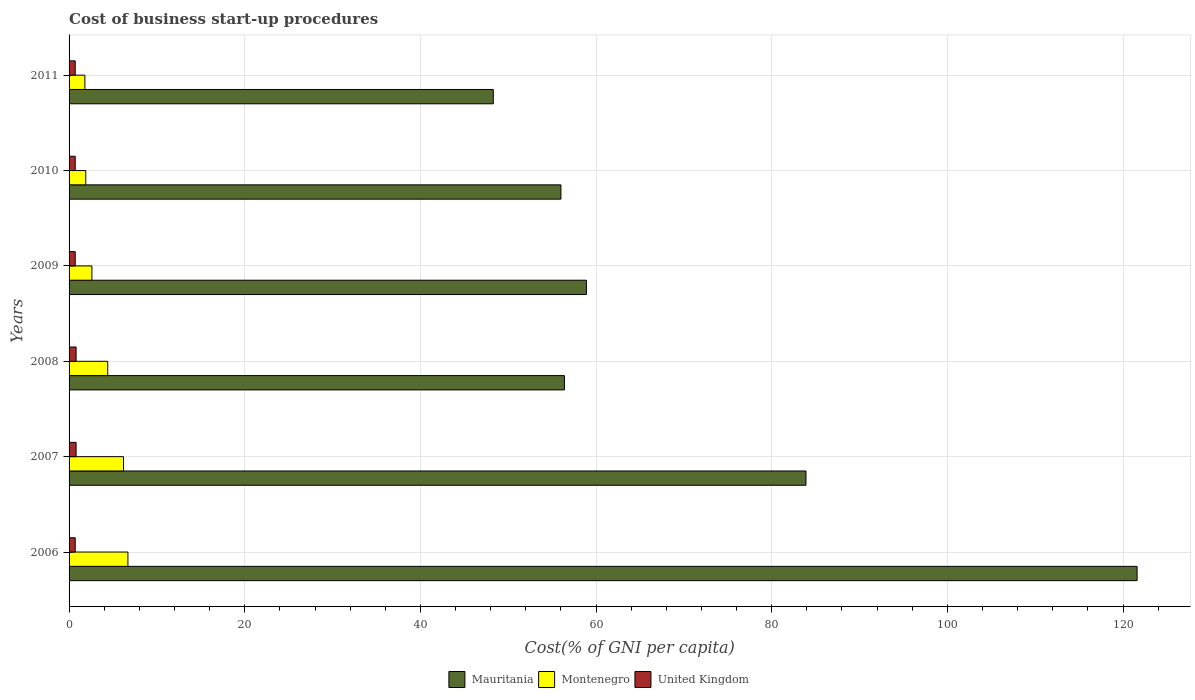How many groups of bars are there?
Give a very brief answer. 6. How many bars are there on the 3rd tick from the bottom?
Your answer should be very brief. 3. What is the label of the 2nd group of bars from the top?
Your answer should be compact. 2010. What is the cost of business start-up procedures in Montenegro in 2006?
Make the answer very short. 6.7. Across all years, what is the maximum cost of business start-up procedures in Mauritania?
Provide a short and direct response. 121.6. Across all years, what is the minimum cost of business start-up procedures in United Kingdom?
Make the answer very short. 0.7. What is the total cost of business start-up procedures in Mauritania in the graph?
Your answer should be very brief. 425.1. What is the difference between the cost of business start-up procedures in United Kingdom in 2008 and that in 2009?
Provide a succinct answer. 0.1. What is the difference between the cost of business start-up procedures in Mauritania in 2010 and the cost of business start-up procedures in Montenegro in 2011?
Make the answer very short. 54.2. What is the average cost of business start-up procedures in Montenegro per year?
Give a very brief answer. 3.93. In the year 2010, what is the difference between the cost of business start-up procedures in Mauritania and cost of business start-up procedures in Montenegro?
Provide a short and direct response. 54.1. What is the ratio of the cost of business start-up procedures in Montenegro in 2007 to that in 2010?
Provide a succinct answer. 3.26. Is the cost of business start-up procedures in Mauritania in 2006 less than that in 2008?
Keep it short and to the point. No. What is the difference between the highest and the second highest cost of business start-up procedures in Mauritania?
Provide a short and direct response. 37.7. What is the difference between the highest and the lowest cost of business start-up procedures in Mauritania?
Offer a terse response. 73.3. In how many years, is the cost of business start-up procedures in United Kingdom greater than the average cost of business start-up procedures in United Kingdom taken over all years?
Make the answer very short. 2. Is the sum of the cost of business start-up procedures in Mauritania in 2010 and 2011 greater than the maximum cost of business start-up procedures in Montenegro across all years?
Your answer should be compact. Yes. What does the 2nd bar from the top in 2008 represents?
Keep it short and to the point. Montenegro. What does the 2nd bar from the bottom in 2007 represents?
Your response must be concise. Montenegro. Is it the case that in every year, the sum of the cost of business start-up procedures in United Kingdom and cost of business start-up procedures in Mauritania is greater than the cost of business start-up procedures in Montenegro?
Provide a short and direct response. Yes. Are all the bars in the graph horizontal?
Your response must be concise. Yes. How many years are there in the graph?
Your response must be concise. 6. What is the difference between two consecutive major ticks on the X-axis?
Ensure brevity in your answer.  20. Are the values on the major ticks of X-axis written in scientific E-notation?
Provide a succinct answer. No. Does the graph contain any zero values?
Ensure brevity in your answer.  No. Does the graph contain grids?
Provide a short and direct response. Yes. How are the legend labels stacked?
Make the answer very short. Horizontal. What is the title of the graph?
Your response must be concise. Cost of business start-up procedures. Does "India" appear as one of the legend labels in the graph?
Provide a short and direct response. No. What is the label or title of the X-axis?
Provide a succinct answer. Cost(% of GNI per capita). What is the label or title of the Y-axis?
Provide a short and direct response. Years. What is the Cost(% of GNI per capita) in Mauritania in 2006?
Provide a succinct answer. 121.6. What is the Cost(% of GNI per capita) of Montenegro in 2006?
Provide a short and direct response. 6.7. What is the Cost(% of GNI per capita) of Mauritania in 2007?
Ensure brevity in your answer.  83.9. What is the Cost(% of GNI per capita) of Mauritania in 2008?
Offer a very short reply. 56.4. What is the Cost(% of GNI per capita) in Mauritania in 2009?
Offer a terse response. 58.9. What is the Cost(% of GNI per capita) in Montenegro in 2009?
Provide a succinct answer. 2.6. What is the Cost(% of GNI per capita) in Mauritania in 2010?
Ensure brevity in your answer.  56. What is the Cost(% of GNI per capita) of Montenegro in 2010?
Offer a terse response. 1.9. What is the Cost(% of GNI per capita) of Mauritania in 2011?
Your response must be concise. 48.3. Across all years, what is the maximum Cost(% of GNI per capita) of Mauritania?
Provide a succinct answer. 121.6. Across all years, what is the minimum Cost(% of GNI per capita) of Mauritania?
Your answer should be compact. 48.3. Across all years, what is the minimum Cost(% of GNI per capita) of Montenegro?
Ensure brevity in your answer.  1.8. What is the total Cost(% of GNI per capita) in Mauritania in the graph?
Offer a terse response. 425.1. What is the total Cost(% of GNI per capita) in Montenegro in the graph?
Your answer should be compact. 23.6. What is the total Cost(% of GNI per capita) in United Kingdom in the graph?
Offer a terse response. 4.4. What is the difference between the Cost(% of GNI per capita) in Mauritania in 2006 and that in 2007?
Provide a succinct answer. 37.7. What is the difference between the Cost(% of GNI per capita) of Mauritania in 2006 and that in 2008?
Make the answer very short. 65.2. What is the difference between the Cost(% of GNI per capita) in Montenegro in 2006 and that in 2008?
Offer a terse response. 2.3. What is the difference between the Cost(% of GNI per capita) in United Kingdom in 2006 and that in 2008?
Your response must be concise. -0.1. What is the difference between the Cost(% of GNI per capita) in Mauritania in 2006 and that in 2009?
Keep it short and to the point. 62.7. What is the difference between the Cost(% of GNI per capita) of Montenegro in 2006 and that in 2009?
Make the answer very short. 4.1. What is the difference between the Cost(% of GNI per capita) of United Kingdom in 2006 and that in 2009?
Keep it short and to the point. 0. What is the difference between the Cost(% of GNI per capita) of Mauritania in 2006 and that in 2010?
Provide a short and direct response. 65.6. What is the difference between the Cost(% of GNI per capita) of Mauritania in 2006 and that in 2011?
Offer a terse response. 73.3. What is the difference between the Cost(% of GNI per capita) in Mauritania in 2007 and that in 2008?
Your answer should be very brief. 27.5. What is the difference between the Cost(% of GNI per capita) in Montenegro in 2007 and that in 2008?
Your answer should be very brief. 1.8. What is the difference between the Cost(% of GNI per capita) of United Kingdom in 2007 and that in 2008?
Make the answer very short. 0. What is the difference between the Cost(% of GNI per capita) of Montenegro in 2007 and that in 2009?
Offer a very short reply. 3.6. What is the difference between the Cost(% of GNI per capita) in United Kingdom in 2007 and that in 2009?
Provide a succinct answer. 0.1. What is the difference between the Cost(% of GNI per capita) in Mauritania in 2007 and that in 2010?
Your answer should be compact. 27.9. What is the difference between the Cost(% of GNI per capita) in United Kingdom in 2007 and that in 2010?
Give a very brief answer. 0.1. What is the difference between the Cost(% of GNI per capita) in Mauritania in 2007 and that in 2011?
Ensure brevity in your answer.  35.6. What is the difference between the Cost(% of GNI per capita) in United Kingdom in 2007 and that in 2011?
Make the answer very short. 0.1. What is the difference between the Cost(% of GNI per capita) in Montenegro in 2008 and that in 2009?
Offer a terse response. 1.8. What is the difference between the Cost(% of GNI per capita) in Montenegro in 2008 and that in 2010?
Your answer should be compact. 2.5. What is the difference between the Cost(% of GNI per capita) in United Kingdom in 2008 and that in 2010?
Ensure brevity in your answer.  0.1. What is the difference between the Cost(% of GNI per capita) of Montenegro in 2008 and that in 2011?
Offer a very short reply. 2.6. What is the difference between the Cost(% of GNI per capita) of Mauritania in 2009 and that in 2010?
Provide a succinct answer. 2.9. What is the difference between the Cost(% of GNI per capita) in Montenegro in 2009 and that in 2010?
Keep it short and to the point. 0.7. What is the difference between the Cost(% of GNI per capita) of United Kingdom in 2009 and that in 2010?
Ensure brevity in your answer.  0. What is the difference between the Cost(% of GNI per capita) in Mauritania in 2009 and that in 2011?
Make the answer very short. 10.6. What is the difference between the Cost(% of GNI per capita) of Mauritania in 2010 and that in 2011?
Ensure brevity in your answer.  7.7. What is the difference between the Cost(% of GNI per capita) in Mauritania in 2006 and the Cost(% of GNI per capita) in Montenegro in 2007?
Keep it short and to the point. 115.4. What is the difference between the Cost(% of GNI per capita) of Mauritania in 2006 and the Cost(% of GNI per capita) of United Kingdom in 2007?
Your response must be concise. 120.8. What is the difference between the Cost(% of GNI per capita) of Montenegro in 2006 and the Cost(% of GNI per capita) of United Kingdom in 2007?
Provide a short and direct response. 5.9. What is the difference between the Cost(% of GNI per capita) in Mauritania in 2006 and the Cost(% of GNI per capita) in Montenegro in 2008?
Your response must be concise. 117.2. What is the difference between the Cost(% of GNI per capita) of Mauritania in 2006 and the Cost(% of GNI per capita) of United Kingdom in 2008?
Your response must be concise. 120.8. What is the difference between the Cost(% of GNI per capita) in Montenegro in 2006 and the Cost(% of GNI per capita) in United Kingdom in 2008?
Offer a terse response. 5.9. What is the difference between the Cost(% of GNI per capita) in Mauritania in 2006 and the Cost(% of GNI per capita) in Montenegro in 2009?
Your answer should be very brief. 119. What is the difference between the Cost(% of GNI per capita) of Mauritania in 2006 and the Cost(% of GNI per capita) of United Kingdom in 2009?
Keep it short and to the point. 120.9. What is the difference between the Cost(% of GNI per capita) in Montenegro in 2006 and the Cost(% of GNI per capita) in United Kingdom in 2009?
Make the answer very short. 6. What is the difference between the Cost(% of GNI per capita) in Mauritania in 2006 and the Cost(% of GNI per capita) in Montenegro in 2010?
Your answer should be compact. 119.7. What is the difference between the Cost(% of GNI per capita) in Mauritania in 2006 and the Cost(% of GNI per capita) in United Kingdom in 2010?
Keep it short and to the point. 120.9. What is the difference between the Cost(% of GNI per capita) of Montenegro in 2006 and the Cost(% of GNI per capita) of United Kingdom in 2010?
Offer a terse response. 6. What is the difference between the Cost(% of GNI per capita) of Mauritania in 2006 and the Cost(% of GNI per capita) of Montenegro in 2011?
Offer a very short reply. 119.8. What is the difference between the Cost(% of GNI per capita) in Mauritania in 2006 and the Cost(% of GNI per capita) in United Kingdom in 2011?
Keep it short and to the point. 120.9. What is the difference between the Cost(% of GNI per capita) of Montenegro in 2006 and the Cost(% of GNI per capita) of United Kingdom in 2011?
Give a very brief answer. 6. What is the difference between the Cost(% of GNI per capita) of Mauritania in 2007 and the Cost(% of GNI per capita) of Montenegro in 2008?
Your response must be concise. 79.5. What is the difference between the Cost(% of GNI per capita) of Mauritania in 2007 and the Cost(% of GNI per capita) of United Kingdom in 2008?
Make the answer very short. 83.1. What is the difference between the Cost(% of GNI per capita) of Montenegro in 2007 and the Cost(% of GNI per capita) of United Kingdom in 2008?
Your response must be concise. 5.4. What is the difference between the Cost(% of GNI per capita) in Mauritania in 2007 and the Cost(% of GNI per capita) in Montenegro in 2009?
Provide a short and direct response. 81.3. What is the difference between the Cost(% of GNI per capita) of Mauritania in 2007 and the Cost(% of GNI per capita) of United Kingdom in 2009?
Make the answer very short. 83.2. What is the difference between the Cost(% of GNI per capita) in Montenegro in 2007 and the Cost(% of GNI per capita) in United Kingdom in 2009?
Keep it short and to the point. 5.5. What is the difference between the Cost(% of GNI per capita) in Mauritania in 2007 and the Cost(% of GNI per capita) in United Kingdom in 2010?
Offer a very short reply. 83.2. What is the difference between the Cost(% of GNI per capita) of Mauritania in 2007 and the Cost(% of GNI per capita) of Montenegro in 2011?
Provide a succinct answer. 82.1. What is the difference between the Cost(% of GNI per capita) of Mauritania in 2007 and the Cost(% of GNI per capita) of United Kingdom in 2011?
Your answer should be very brief. 83.2. What is the difference between the Cost(% of GNI per capita) of Montenegro in 2007 and the Cost(% of GNI per capita) of United Kingdom in 2011?
Provide a short and direct response. 5.5. What is the difference between the Cost(% of GNI per capita) in Mauritania in 2008 and the Cost(% of GNI per capita) in Montenegro in 2009?
Your answer should be very brief. 53.8. What is the difference between the Cost(% of GNI per capita) in Mauritania in 2008 and the Cost(% of GNI per capita) in United Kingdom in 2009?
Your response must be concise. 55.7. What is the difference between the Cost(% of GNI per capita) in Montenegro in 2008 and the Cost(% of GNI per capita) in United Kingdom in 2009?
Make the answer very short. 3.7. What is the difference between the Cost(% of GNI per capita) in Mauritania in 2008 and the Cost(% of GNI per capita) in Montenegro in 2010?
Provide a short and direct response. 54.5. What is the difference between the Cost(% of GNI per capita) of Mauritania in 2008 and the Cost(% of GNI per capita) of United Kingdom in 2010?
Ensure brevity in your answer.  55.7. What is the difference between the Cost(% of GNI per capita) in Montenegro in 2008 and the Cost(% of GNI per capita) in United Kingdom in 2010?
Offer a terse response. 3.7. What is the difference between the Cost(% of GNI per capita) of Mauritania in 2008 and the Cost(% of GNI per capita) of Montenegro in 2011?
Your response must be concise. 54.6. What is the difference between the Cost(% of GNI per capita) in Mauritania in 2008 and the Cost(% of GNI per capita) in United Kingdom in 2011?
Keep it short and to the point. 55.7. What is the difference between the Cost(% of GNI per capita) in Mauritania in 2009 and the Cost(% of GNI per capita) in Montenegro in 2010?
Give a very brief answer. 57. What is the difference between the Cost(% of GNI per capita) in Mauritania in 2009 and the Cost(% of GNI per capita) in United Kingdom in 2010?
Offer a very short reply. 58.2. What is the difference between the Cost(% of GNI per capita) in Montenegro in 2009 and the Cost(% of GNI per capita) in United Kingdom in 2010?
Your answer should be very brief. 1.9. What is the difference between the Cost(% of GNI per capita) in Mauritania in 2009 and the Cost(% of GNI per capita) in Montenegro in 2011?
Your response must be concise. 57.1. What is the difference between the Cost(% of GNI per capita) of Mauritania in 2009 and the Cost(% of GNI per capita) of United Kingdom in 2011?
Your answer should be compact. 58.2. What is the difference between the Cost(% of GNI per capita) of Montenegro in 2009 and the Cost(% of GNI per capita) of United Kingdom in 2011?
Ensure brevity in your answer.  1.9. What is the difference between the Cost(% of GNI per capita) in Mauritania in 2010 and the Cost(% of GNI per capita) in Montenegro in 2011?
Ensure brevity in your answer.  54.2. What is the difference between the Cost(% of GNI per capita) of Mauritania in 2010 and the Cost(% of GNI per capita) of United Kingdom in 2011?
Offer a very short reply. 55.3. What is the difference between the Cost(% of GNI per capita) in Montenegro in 2010 and the Cost(% of GNI per capita) in United Kingdom in 2011?
Ensure brevity in your answer.  1.2. What is the average Cost(% of GNI per capita) of Mauritania per year?
Give a very brief answer. 70.85. What is the average Cost(% of GNI per capita) in Montenegro per year?
Ensure brevity in your answer.  3.93. What is the average Cost(% of GNI per capita) in United Kingdom per year?
Give a very brief answer. 0.73. In the year 2006, what is the difference between the Cost(% of GNI per capita) of Mauritania and Cost(% of GNI per capita) of Montenegro?
Provide a short and direct response. 114.9. In the year 2006, what is the difference between the Cost(% of GNI per capita) of Mauritania and Cost(% of GNI per capita) of United Kingdom?
Your answer should be compact. 120.9. In the year 2007, what is the difference between the Cost(% of GNI per capita) in Mauritania and Cost(% of GNI per capita) in Montenegro?
Provide a succinct answer. 77.7. In the year 2007, what is the difference between the Cost(% of GNI per capita) in Mauritania and Cost(% of GNI per capita) in United Kingdom?
Ensure brevity in your answer.  83.1. In the year 2007, what is the difference between the Cost(% of GNI per capita) in Montenegro and Cost(% of GNI per capita) in United Kingdom?
Make the answer very short. 5.4. In the year 2008, what is the difference between the Cost(% of GNI per capita) of Mauritania and Cost(% of GNI per capita) of United Kingdom?
Ensure brevity in your answer.  55.6. In the year 2009, what is the difference between the Cost(% of GNI per capita) in Mauritania and Cost(% of GNI per capita) in Montenegro?
Your answer should be compact. 56.3. In the year 2009, what is the difference between the Cost(% of GNI per capita) of Mauritania and Cost(% of GNI per capita) of United Kingdom?
Your answer should be very brief. 58.2. In the year 2009, what is the difference between the Cost(% of GNI per capita) of Montenegro and Cost(% of GNI per capita) of United Kingdom?
Ensure brevity in your answer.  1.9. In the year 2010, what is the difference between the Cost(% of GNI per capita) in Mauritania and Cost(% of GNI per capita) in Montenegro?
Offer a terse response. 54.1. In the year 2010, what is the difference between the Cost(% of GNI per capita) of Mauritania and Cost(% of GNI per capita) of United Kingdom?
Offer a very short reply. 55.3. In the year 2011, what is the difference between the Cost(% of GNI per capita) in Mauritania and Cost(% of GNI per capita) in Montenegro?
Your answer should be compact. 46.5. In the year 2011, what is the difference between the Cost(% of GNI per capita) in Mauritania and Cost(% of GNI per capita) in United Kingdom?
Your response must be concise. 47.6. What is the ratio of the Cost(% of GNI per capita) of Mauritania in 2006 to that in 2007?
Provide a short and direct response. 1.45. What is the ratio of the Cost(% of GNI per capita) in Montenegro in 2006 to that in 2007?
Offer a very short reply. 1.08. What is the ratio of the Cost(% of GNI per capita) of Mauritania in 2006 to that in 2008?
Offer a very short reply. 2.16. What is the ratio of the Cost(% of GNI per capita) in Montenegro in 2006 to that in 2008?
Offer a terse response. 1.52. What is the ratio of the Cost(% of GNI per capita) in Mauritania in 2006 to that in 2009?
Your answer should be compact. 2.06. What is the ratio of the Cost(% of GNI per capita) of Montenegro in 2006 to that in 2009?
Keep it short and to the point. 2.58. What is the ratio of the Cost(% of GNI per capita) in Mauritania in 2006 to that in 2010?
Provide a short and direct response. 2.17. What is the ratio of the Cost(% of GNI per capita) in Montenegro in 2006 to that in 2010?
Your answer should be very brief. 3.53. What is the ratio of the Cost(% of GNI per capita) in Mauritania in 2006 to that in 2011?
Give a very brief answer. 2.52. What is the ratio of the Cost(% of GNI per capita) of Montenegro in 2006 to that in 2011?
Offer a terse response. 3.72. What is the ratio of the Cost(% of GNI per capita) of United Kingdom in 2006 to that in 2011?
Provide a succinct answer. 1. What is the ratio of the Cost(% of GNI per capita) of Mauritania in 2007 to that in 2008?
Offer a very short reply. 1.49. What is the ratio of the Cost(% of GNI per capita) in Montenegro in 2007 to that in 2008?
Your answer should be very brief. 1.41. What is the ratio of the Cost(% of GNI per capita) in Mauritania in 2007 to that in 2009?
Offer a terse response. 1.42. What is the ratio of the Cost(% of GNI per capita) in Montenegro in 2007 to that in 2009?
Give a very brief answer. 2.38. What is the ratio of the Cost(% of GNI per capita) of United Kingdom in 2007 to that in 2009?
Give a very brief answer. 1.14. What is the ratio of the Cost(% of GNI per capita) in Mauritania in 2007 to that in 2010?
Provide a succinct answer. 1.5. What is the ratio of the Cost(% of GNI per capita) in Montenegro in 2007 to that in 2010?
Your answer should be compact. 3.26. What is the ratio of the Cost(% of GNI per capita) in Mauritania in 2007 to that in 2011?
Keep it short and to the point. 1.74. What is the ratio of the Cost(% of GNI per capita) of Montenegro in 2007 to that in 2011?
Keep it short and to the point. 3.44. What is the ratio of the Cost(% of GNI per capita) of United Kingdom in 2007 to that in 2011?
Give a very brief answer. 1.14. What is the ratio of the Cost(% of GNI per capita) of Mauritania in 2008 to that in 2009?
Offer a very short reply. 0.96. What is the ratio of the Cost(% of GNI per capita) in Montenegro in 2008 to that in 2009?
Provide a succinct answer. 1.69. What is the ratio of the Cost(% of GNI per capita) of Mauritania in 2008 to that in 2010?
Ensure brevity in your answer.  1.01. What is the ratio of the Cost(% of GNI per capita) of Montenegro in 2008 to that in 2010?
Your response must be concise. 2.32. What is the ratio of the Cost(% of GNI per capita) of Mauritania in 2008 to that in 2011?
Your answer should be very brief. 1.17. What is the ratio of the Cost(% of GNI per capita) of Montenegro in 2008 to that in 2011?
Give a very brief answer. 2.44. What is the ratio of the Cost(% of GNI per capita) of United Kingdom in 2008 to that in 2011?
Make the answer very short. 1.14. What is the ratio of the Cost(% of GNI per capita) in Mauritania in 2009 to that in 2010?
Give a very brief answer. 1.05. What is the ratio of the Cost(% of GNI per capita) in Montenegro in 2009 to that in 2010?
Make the answer very short. 1.37. What is the ratio of the Cost(% of GNI per capita) of Mauritania in 2009 to that in 2011?
Your response must be concise. 1.22. What is the ratio of the Cost(% of GNI per capita) in Montenegro in 2009 to that in 2011?
Ensure brevity in your answer.  1.44. What is the ratio of the Cost(% of GNI per capita) of United Kingdom in 2009 to that in 2011?
Give a very brief answer. 1. What is the ratio of the Cost(% of GNI per capita) in Mauritania in 2010 to that in 2011?
Provide a succinct answer. 1.16. What is the ratio of the Cost(% of GNI per capita) in Montenegro in 2010 to that in 2011?
Provide a short and direct response. 1.06. What is the ratio of the Cost(% of GNI per capita) of United Kingdom in 2010 to that in 2011?
Provide a succinct answer. 1. What is the difference between the highest and the second highest Cost(% of GNI per capita) in Mauritania?
Provide a succinct answer. 37.7. What is the difference between the highest and the lowest Cost(% of GNI per capita) of Mauritania?
Make the answer very short. 73.3. What is the difference between the highest and the lowest Cost(% of GNI per capita) of United Kingdom?
Offer a terse response. 0.1. 